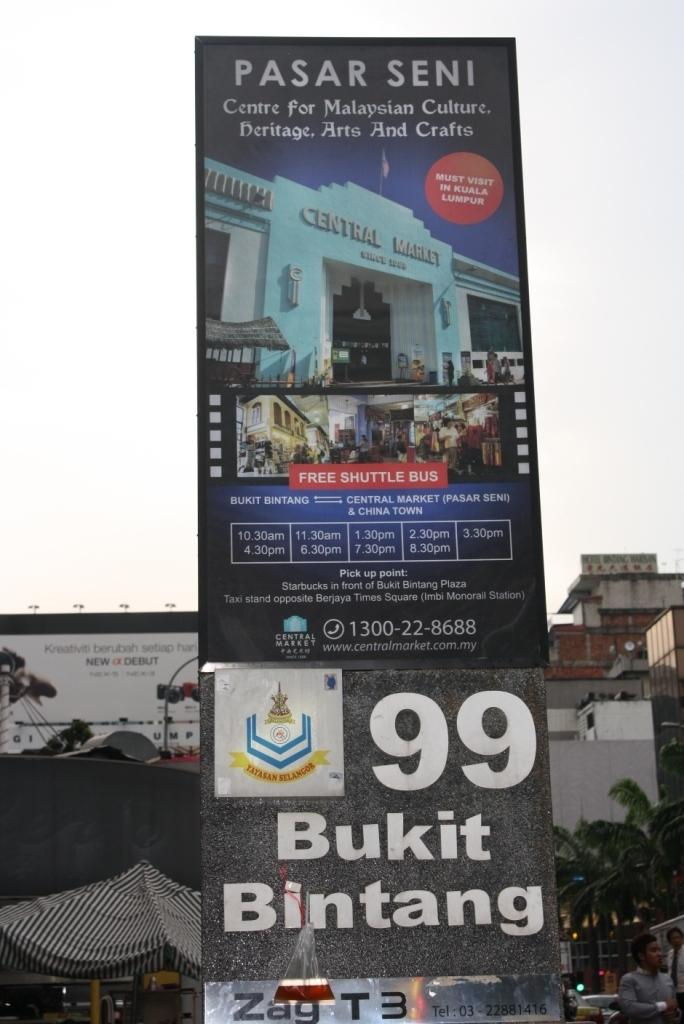<image>
Summarize the visual content of the image. Big sign that says bukit bintang and Pasar Seni 